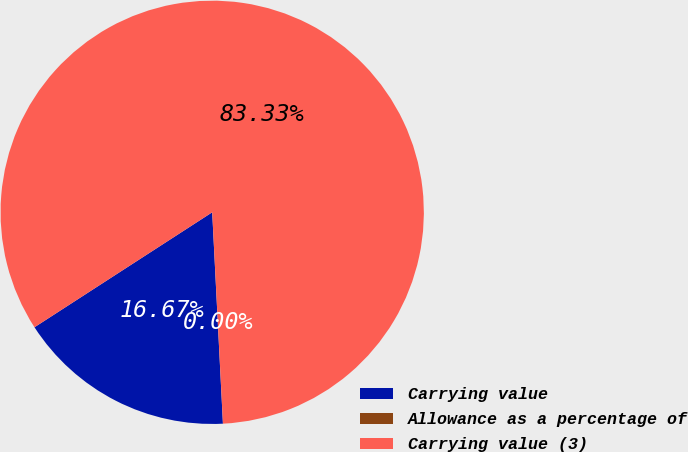Convert chart to OTSL. <chart><loc_0><loc_0><loc_500><loc_500><pie_chart><fcel>Carrying value<fcel>Allowance as a percentage of<fcel>Carrying value (3)<nl><fcel>16.67%<fcel>0.0%<fcel>83.33%<nl></chart> 